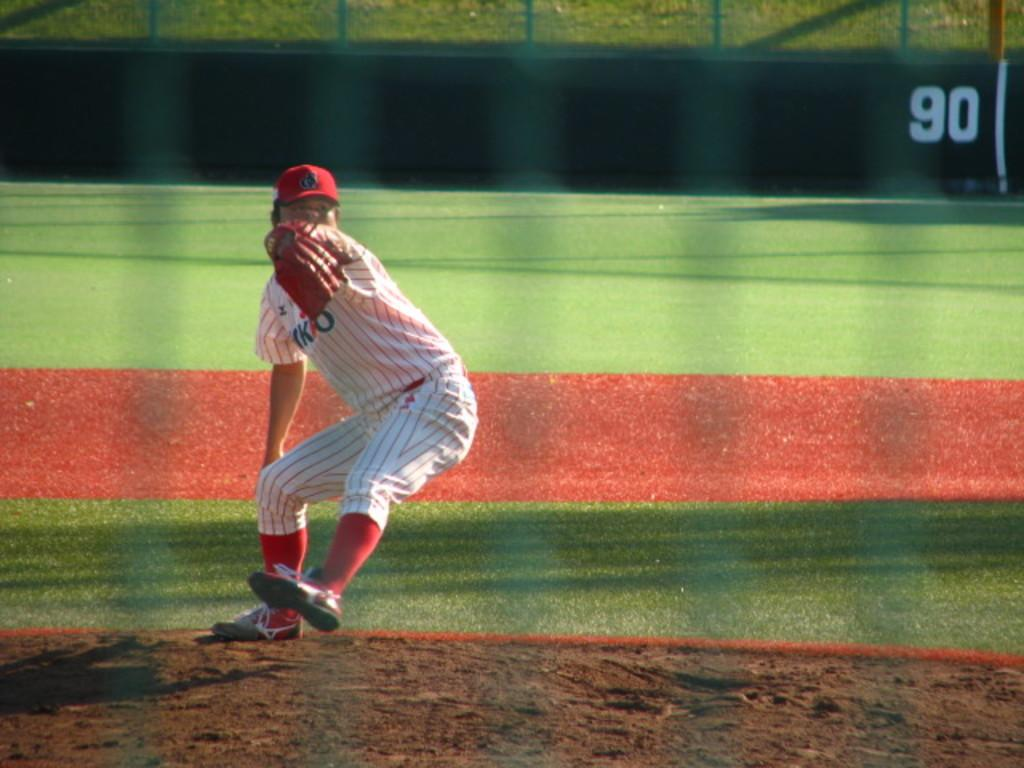What is the main subject of the image? There is a baseball player in the image. What is the baseball player doing in the image? The baseball player is in a playing position. What can be seen behind the baseball player? There is a ground visible behind the player. Can you see a monkey playing with a spot in the image? No, there is no monkey or spot present in the image. 